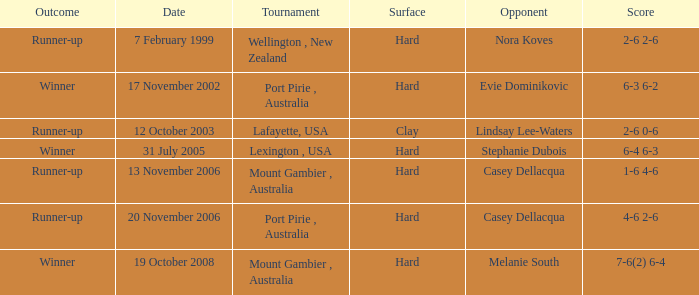Which Tournament has an Outcome of winner on 19 october 2008? Mount Gambier , Australia. 